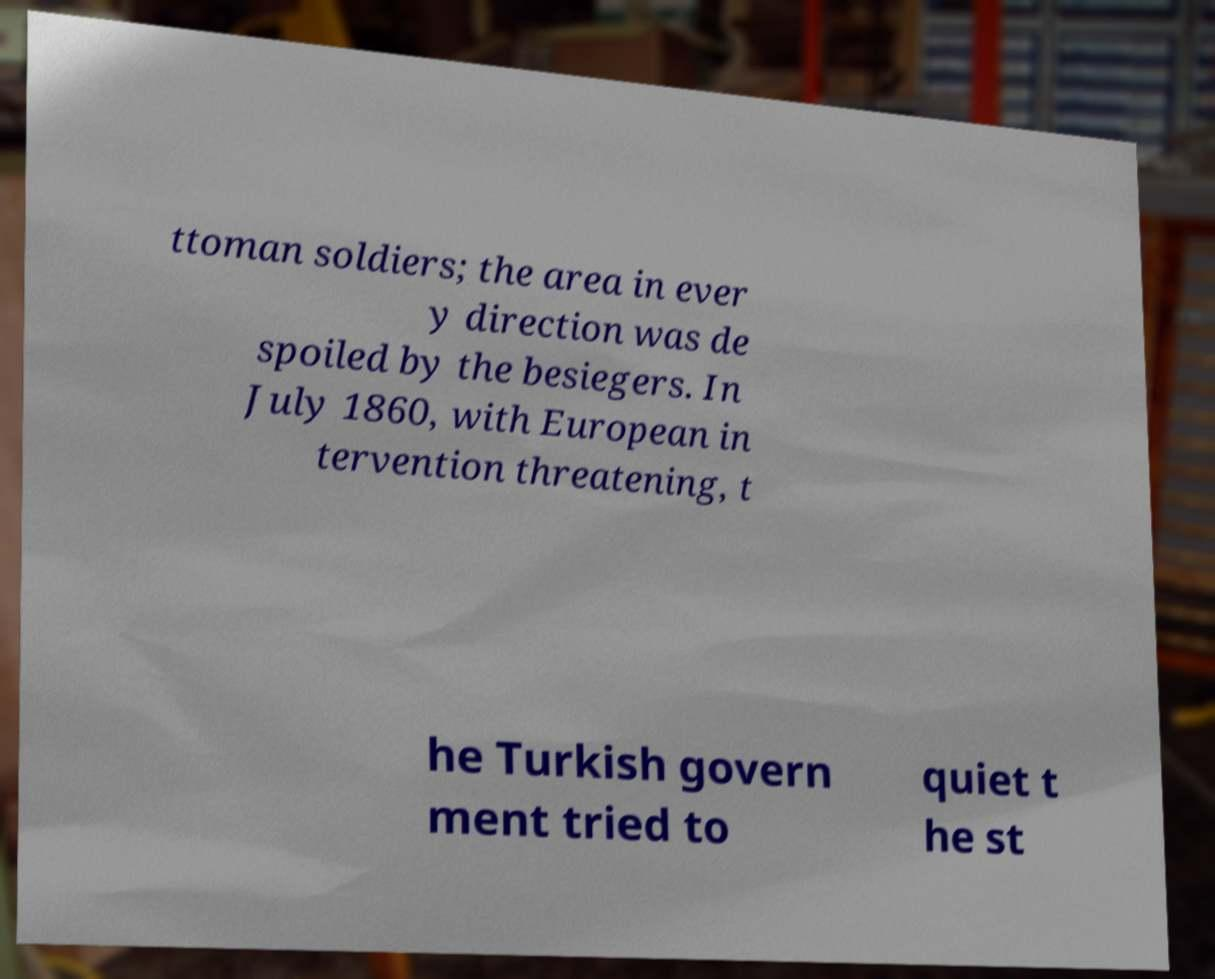What messages or text are displayed in this image? I need them in a readable, typed format. ttoman soldiers; the area in ever y direction was de spoiled by the besiegers. In July 1860, with European in tervention threatening, t he Turkish govern ment tried to quiet t he st 